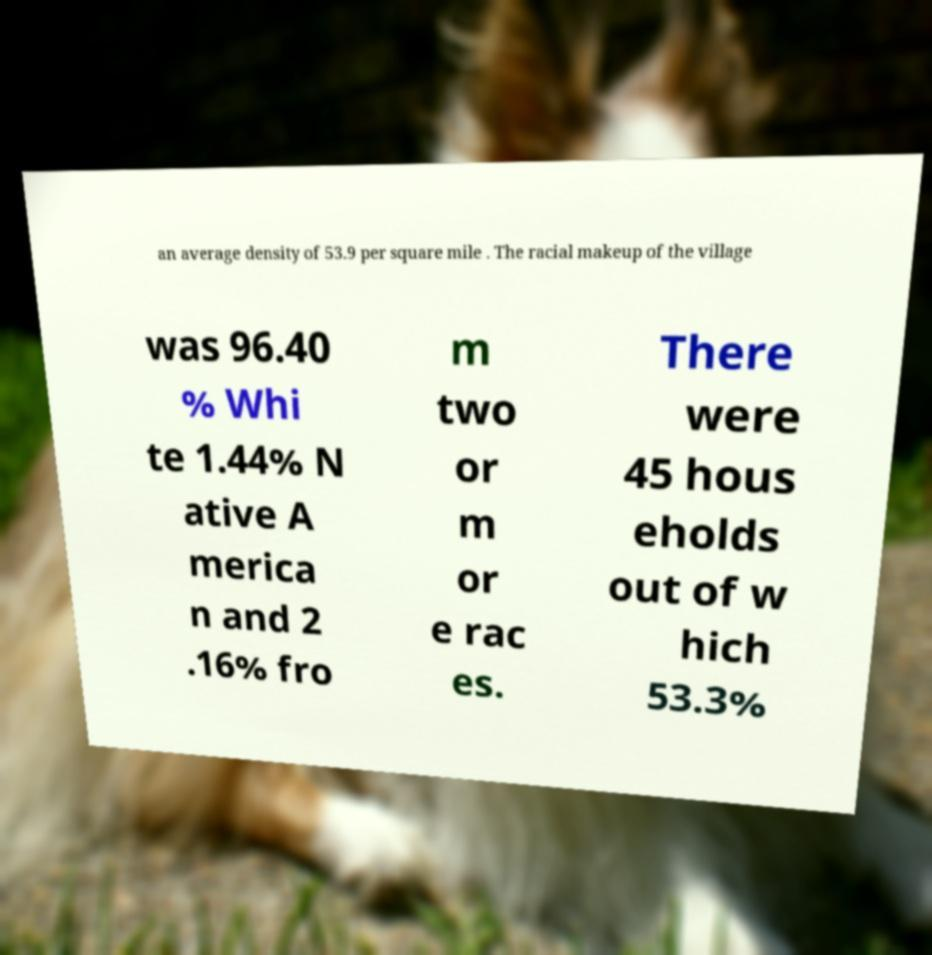Please identify and transcribe the text found in this image. an average density of 53.9 per square mile . The racial makeup of the village was 96.40 % Whi te 1.44% N ative A merica n and 2 .16% fro m two or m or e rac es. There were 45 hous eholds out of w hich 53.3% 